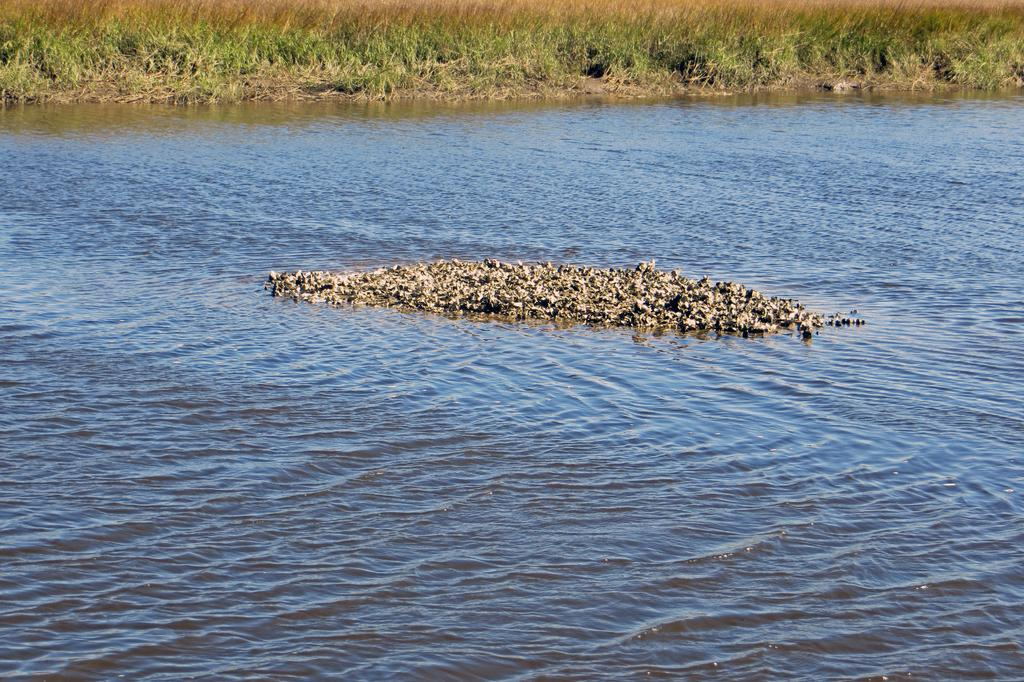What type of animals can be seen in the image? Birds can be seen in the water. What type of vegetation is visible in the image? There is grass visible in the image. What impulse causes the baseball to move in the image? There is no baseball present in the image, so the question cannot be answered. 